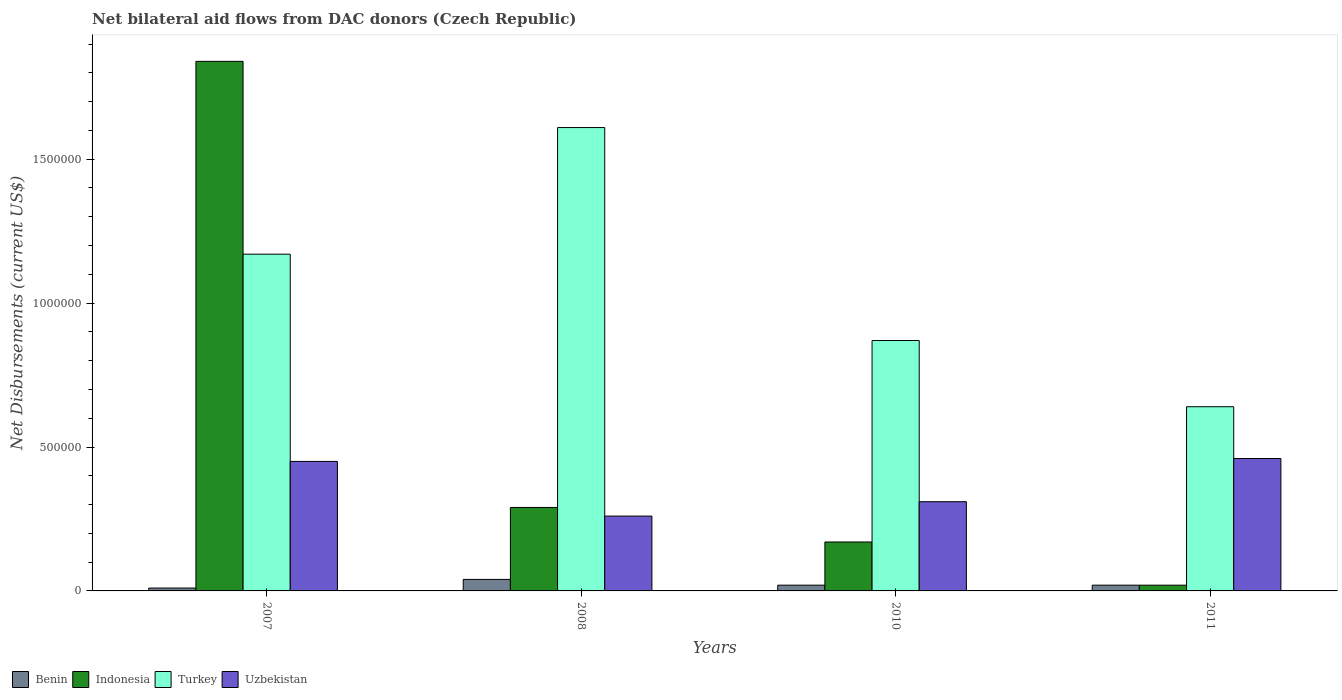How many different coloured bars are there?
Ensure brevity in your answer.  4. How many groups of bars are there?
Give a very brief answer. 4. How many bars are there on the 1st tick from the right?
Your answer should be compact. 4. What is the label of the 4th group of bars from the left?
Your response must be concise. 2011. In how many cases, is the number of bars for a given year not equal to the number of legend labels?
Keep it short and to the point. 0. What is the net bilateral aid flows in Turkey in 2008?
Your answer should be very brief. 1.61e+06. Across all years, what is the minimum net bilateral aid flows in Turkey?
Keep it short and to the point. 6.40e+05. In which year was the net bilateral aid flows in Uzbekistan minimum?
Your answer should be very brief. 2008. What is the total net bilateral aid flows in Indonesia in the graph?
Give a very brief answer. 2.32e+06. What is the difference between the net bilateral aid flows in Turkey in 2008 and that in 2011?
Ensure brevity in your answer.  9.70e+05. What is the difference between the net bilateral aid flows in Turkey in 2007 and the net bilateral aid flows in Benin in 2008?
Your answer should be very brief. 1.13e+06. What is the average net bilateral aid flows in Indonesia per year?
Offer a terse response. 5.80e+05. In the year 2011, what is the difference between the net bilateral aid flows in Benin and net bilateral aid flows in Uzbekistan?
Give a very brief answer. -4.40e+05. In how many years, is the net bilateral aid flows in Uzbekistan greater than 800000 US$?
Provide a short and direct response. 0. What is the difference between the highest and the lowest net bilateral aid flows in Turkey?
Offer a very short reply. 9.70e+05. What does the 4th bar from the left in 2008 represents?
Keep it short and to the point. Uzbekistan. What does the 1st bar from the right in 2008 represents?
Provide a succinct answer. Uzbekistan. Is it the case that in every year, the sum of the net bilateral aid flows in Turkey and net bilateral aid flows in Indonesia is greater than the net bilateral aid flows in Uzbekistan?
Give a very brief answer. Yes. Are the values on the major ticks of Y-axis written in scientific E-notation?
Offer a terse response. No. Does the graph contain any zero values?
Your answer should be very brief. No. Where does the legend appear in the graph?
Provide a short and direct response. Bottom left. How many legend labels are there?
Make the answer very short. 4. What is the title of the graph?
Keep it short and to the point. Net bilateral aid flows from DAC donors (Czech Republic). What is the label or title of the Y-axis?
Make the answer very short. Net Disbursements (current US$). What is the Net Disbursements (current US$) of Indonesia in 2007?
Ensure brevity in your answer.  1.84e+06. What is the Net Disbursements (current US$) of Turkey in 2007?
Keep it short and to the point. 1.17e+06. What is the Net Disbursements (current US$) of Indonesia in 2008?
Your response must be concise. 2.90e+05. What is the Net Disbursements (current US$) in Turkey in 2008?
Your response must be concise. 1.61e+06. What is the Net Disbursements (current US$) of Uzbekistan in 2008?
Make the answer very short. 2.60e+05. What is the Net Disbursements (current US$) in Indonesia in 2010?
Provide a short and direct response. 1.70e+05. What is the Net Disbursements (current US$) of Turkey in 2010?
Offer a very short reply. 8.70e+05. What is the Net Disbursements (current US$) of Uzbekistan in 2010?
Your answer should be very brief. 3.10e+05. What is the Net Disbursements (current US$) of Turkey in 2011?
Your answer should be very brief. 6.40e+05. Across all years, what is the maximum Net Disbursements (current US$) of Indonesia?
Your answer should be very brief. 1.84e+06. Across all years, what is the maximum Net Disbursements (current US$) in Turkey?
Keep it short and to the point. 1.61e+06. Across all years, what is the maximum Net Disbursements (current US$) of Uzbekistan?
Offer a terse response. 4.60e+05. Across all years, what is the minimum Net Disbursements (current US$) in Benin?
Your response must be concise. 10000. Across all years, what is the minimum Net Disbursements (current US$) of Indonesia?
Offer a terse response. 2.00e+04. Across all years, what is the minimum Net Disbursements (current US$) of Turkey?
Your answer should be compact. 6.40e+05. Across all years, what is the minimum Net Disbursements (current US$) of Uzbekistan?
Your response must be concise. 2.60e+05. What is the total Net Disbursements (current US$) in Indonesia in the graph?
Give a very brief answer. 2.32e+06. What is the total Net Disbursements (current US$) of Turkey in the graph?
Make the answer very short. 4.29e+06. What is the total Net Disbursements (current US$) in Uzbekistan in the graph?
Provide a succinct answer. 1.48e+06. What is the difference between the Net Disbursements (current US$) of Benin in 2007 and that in 2008?
Your answer should be very brief. -3.00e+04. What is the difference between the Net Disbursements (current US$) of Indonesia in 2007 and that in 2008?
Provide a short and direct response. 1.55e+06. What is the difference between the Net Disbursements (current US$) of Turkey in 2007 and that in 2008?
Offer a very short reply. -4.40e+05. What is the difference between the Net Disbursements (current US$) of Uzbekistan in 2007 and that in 2008?
Offer a terse response. 1.90e+05. What is the difference between the Net Disbursements (current US$) in Benin in 2007 and that in 2010?
Give a very brief answer. -10000. What is the difference between the Net Disbursements (current US$) in Indonesia in 2007 and that in 2010?
Give a very brief answer. 1.67e+06. What is the difference between the Net Disbursements (current US$) in Benin in 2007 and that in 2011?
Your response must be concise. -10000. What is the difference between the Net Disbursements (current US$) of Indonesia in 2007 and that in 2011?
Provide a succinct answer. 1.82e+06. What is the difference between the Net Disbursements (current US$) in Turkey in 2007 and that in 2011?
Provide a short and direct response. 5.30e+05. What is the difference between the Net Disbursements (current US$) in Turkey in 2008 and that in 2010?
Your answer should be very brief. 7.40e+05. What is the difference between the Net Disbursements (current US$) of Benin in 2008 and that in 2011?
Offer a terse response. 2.00e+04. What is the difference between the Net Disbursements (current US$) of Turkey in 2008 and that in 2011?
Ensure brevity in your answer.  9.70e+05. What is the difference between the Net Disbursements (current US$) in Benin in 2010 and that in 2011?
Make the answer very short. 0. What is the difference between the Net Disbursements (current US$) of Indonesia in 2010 and that in 2011?
Offer a terse response. 1.50e+05. What is the difference between the Net Disbursements (current US$) of Turkey in 2010 and that in 2011?
Provide a short and direct response. 2.30e+05. What is the difference between the Net Disbursements (current US$) in Benin in 2007 and the Net Disbursements (current US$) in Indonesia in 2008?
Offer a terse response. -2.80e+05. What is the difference between the Net Disbursements (current US$) in Benin in 2007 and the Net Disbursements (current US$) in Turkey in 2008?
Your answer should be compact. -1.60e+06. What is the difference between the Net Disbursements (current US$) of Benin in 2007 and the Net Disbursements (current US$) of Uzbekistan in 2008?
Make the answer very short. -2.50e+05. What is the difference between the Net Disbursements (current US$) of Indonesia in 2007 and the Net Disbursements (current US$) of Turkey in 2008?
Your answer should be very brief. 2.30e+05. What is the difference between the Net Disbursements (current US$) of Indonesia in 2007 and the Net Disbursements (current US$) of Uzbekistan in 2008?
Keep it short and to the point. 1.58e+06. What is the difference between the Net Disbursements (current US$) of Turkey in 2007 and the Net Disbursements (current US$) of Uzbekistan in 2008?
Your answer should be very brief. 9.10e+05. What is the difference between the Net Disbursements (current US$) in Benin in 2007 and the Net Disbursements (current US$) in Indonesia in 2010?
Ensure brevity in your answer.  -1.60e+05. What is the difference between the Net Disbursements (current US$) in Benin in 2007 and the Net Disbursements (current US$) in Turkey in 2010?
Your answer should be compact. -8.60e+05. What is the difference between the Net Disbursements (current US$) of Benin in 2007 and the Net Disbursements (current US$) of Uzbekistan in 2010?
Provide a succinct answer. -3.00e+05. What is the difference between the Net Disbursements (current US$) of Indonesia in 2007 and the Net Disbursements (current US$) of Turkey in 2010?
Offer a very short reply. 9.70e+05. What is the difference between the Net Disbursements (current US$) in Indonesia in 2007 and the Net Disbursements (current US$) in Uzbekistan in 2010?
Your answer should be compact. 1.53e+06. What is the difference between the Net Disbursements (current US$) in Turkey in 2007 and the Net Disbursements (current US$) in Uzbekistan in 2010?
Make the answer very short. 8.60e+05. What is the difference between the Net Disbursements (current US$) in Benin in 2007 and the Net Disbursements (current US$) in Indonesia in 2011?
Your response must be concise. -10000. What is the difference between the Net Disbursements (current US$) of Benin in 2007 and the Net Disbursements (current US$) of Turkey in 2011?
Your response must be concise. -6.30e+05. What is the difference between the Net Disbursements (current US$) of Benin in 2007 and the Net Disbursements (current US$) of Uzbekistan in 2011?
Keep it short and to the point. -4.50e+05. What is the difference between the Net Disbursements (current US$) of Indonesia in 2007 and the Net Disbursements (current US$) of Turkey in 2011?
Make the answer very short. 1.20e+06. What is the difference between the Net Disbursements (current US$) of Indonesia in 2007 and the Net Disbursements (current US$) of Uzbekistan in 2011?
Keep it short and to the point. 1.38e+06. What is the difference between the Net Disbursements (current US$) in Turkey in 2007 and the Net Disbursements (current US$) in Uzbekistan in 2011?
Make the answer very short. 7.10e+05. What is the difference between the Net Disbursements (current US$) of Benin in 2008 and the Net Disbursements (current US$) of Indonesia in 2010?
Offer a terse response. -1.30e+05. What is the difference between the Net Disbursements (current US$) of Benin in 2008 and the Net Disbursements (current US$) of Turkey in 2010?
Keep it short and to the point. -8.30e+05. What is the difference between the Net Disbursements (current US$) of Benin in 2008 and the Net Disbursements (current US$) of Uzbekistan in 2010?
Your answer should be compact. -2.70e+05. What is the difference between the Net Disbursements (current US$) in Indonesia in 2008 and the Net Disbursements (current US$) in Turkey in 2010?
Offer a very short reply. -5.80e+05. What is the difference between the Net Disbursements (current US$) of Turkey in 2008 and the Net Disbursements (current US$) of Uzbekistan in 2010?
Offer a terse response. 1.30e+06. What is the difference between the Net Disbursements (current US$) of Benin in 2008 and the Net Disbursements (current US$) of Indonesia in 2011?
Provide a succinct answer. 2.00e+04. What is the difference between the Net Disbursements (current US$) of Benin in 2008 and the Net Disbursements (current US$) of Turkey in 2011?
Make the answer very short. -6.00e+05. What is the difference between the Net Disbursements (current US$) in Benin in 2008 and the Net Disbursements (current US$) in Uzbekistan in 2011?
Your answer should be compact. -4.20e+05. What is the difference between the Net Disbursements (current US$) in Indonesia in 2008 and the Net Disbursements (current US$) in Turkey in 2011?
Keep it short and to the point. -3.50e+05. What is the difference between the Net Disbursements (current US$) in Turkey in 2008 and the Net Disbursements (current US$) in Uzbekistan in 2011?
Make the answer very short. 1.15e+06. What is the difference between the Net Disbursements (current US$) of Benin in 2010 and the Net Disbursements (current US$) of Turkey in 2011?
Make the answer very short. -6.20e+05. What is the difference between the Net Disbursements (current US$) in Benin in 2010 and the Net Disbursements (current US$) in Uzbekistan in 2011?
Your answer should be very brief. -4.40e+05. What is the difference between the Net Disbursements (current US$) in Indonesia in 2010 and the Net Disbursements (current US$) in Turkey in 2011?
Your answer should be very brief. -4.70e+05. What is the difference between the Net Disbursements (current US$) in Indonesia in 2010 and the Net Disbursements (current US$) in Uzbekistan in 2011?
Offer a very short reply. -2.90e+05. What is the difference between the Net Disbursements (current US$) in Turkey in 2010 and the Net Disbursements (current US$) in Uzbekistan in 2011?
Provide a short and direct response. 4.10e+05. What is the average Net Disbursements (current US$) in Benin per year?
Offer a very short reply. 2.25e+04. What is the average Net Disbursements (current US$) in Indonesia per year?
Ensure brevity in your answer.  5.80e+05. What is the average Net Disbursements (current US$) in Turkey per year?
Offer a terse response. 1.07e+06. In the year 2007, what is the difference between the Net Disbursements (current US$) in Benin and Net Disbursements (current US$) in Indonesia?
Provide a short and direct response. -1.83e+06. In the year 2007, what is the difference between the Net Disbursements (current US$) of Benin and Net Disbursements (current US$) of Turkey?
Your response must be concise. -1.16e+06. In the year 2007, what is the difference between the Net Disbursements (current US$) of Benin and Net Disbursements (current US$) of Uzbekistan?
Provide a succinct answer. -4.40e+05. In the year 2007, what is the difference between the Net Disbursements (current US$) of Indonesia and Net Disbursements (current US$) of Turkey?
Provide a succinct answer. 6.70e+05. In the year 2007, what is the difference between the Net Disbursements (current US$) in Indonesia and Net Disbursements (current US$) in Uzbekistan?
Your answer should be very brief. 1.39e+06. In the year 2007, what is the difference between the Net Disbursements (current US$) of Turkey and Net Disbursements (current US$) of Uzbekistan?
Ensure brevity in your answer.  7.20e+05. In the year 2008, what is the difference between the Net Disbursements (current US$) of Benin and Net Disbursements (current US$) of Indonesia?
Provide a short and direct response. -2.50e+05. In the year 2008, what is the difference between the Net Disbursements (current US$) in Benin and Net Disbursements (current US$) in Turkey?
Provide a succinct answer. -1.57e+06. In the year 2008, what is the difference between the Net Disbursements (current US$) in Benin and Net Disbursements (current US$) in Uzbekistan?
Your answer should be compact. -2.20e+05. In the year 2008, what is the difference between the Net Disbursements (current US$) of Indonesia and Net Disbursements (current US$) of Turkey?
Provide a succinct answer. -1.32e+06. In the year 2008, what is the difference between the Net Disbursements (current US$) of Indonesia and Net Disbursements (current US$) of Uzbekistan?
Ensure brevity in your answer.  3.00e+04. In the year 2008, what is the difference between the Net Disbursements (current US$) of Turkey and Net Disbursements (current US$) of Uzbekistan?
Your answer should be very brief. 1.35e+06. In the year 2010, what is the difference between the Net Disbursements (current US$) of Benin and Net Disbursements (current US$) of Indonesia?
Your answer should be very brief. -1.50e+05. In the year 2010, what is the difference between the Net Disbursements (current US$) in Benin and Net Disbursements (current US$) in Turkey?
Make the answer very short. -8.50e+05. In the year 2010, what is the difference between the Net Disbursements (current US$) of Benin and Net Disbursements (current US$) of Uzbekistan?
Offer a very short reply. -2.90e+05. In the year 2010, what is the difference between the Net Disbursements (current US$) in Indonesia and Net Disbursements (current US$) in Turkey?
Give a very brief answer. -7.00e+05. In the year 2010, what is the difference between the Net Disbursements (current US$) of Indonesia and Net Disbursements (current US$) of Uzbekistan?
Keep it short and to the point. -1.40e+05. In the year 2010, what is the difference between the Net Disbursements (current US$) of Turkey and Net Disbursements (current US$) of Uzbekistan?
Your answer should be very brief. 5.60e+05. In the year 2011, what is the difference between the Net Disbursements (current US$) in Benin and Net Disbursements (current US$) in Turkey?
Give a very brief answer. -6.20e+05. In the year 2011, what is the difference between the Net Disbursements (current US$) in Benin and Net Disbursements (current US$) in Uzbekistan?
Ensure brevity in your answer.  -4.40e+05. In the year 2011, what is the difference between the Net Disbursements (current US$) in Indonesia and Net Disbursements (current US$) in Turkey?
Make the answer very short. -6.20e+05. In the year 2011, what is the difference between the Net Disbursements (current US$) in Indonesia and Net Disbursements (current US$) in Uzbekistan?
Your answer should be very brief. -4.40e+05. In the year 2011, what is the difference between the Net Disbursements (current US$) of Turkey and Net Disbursements (current US$) of Uzbekistan?
Offer a very short reply. 1.80e+05. What is the ratio of the Net Disbursements (current US$) in Indonesia in 2007 to that in 2008?
Your answer should be compact. 6.34. What is the ratio of the Net Disbursements (current US$) in Turkey in 2007 to that in 2008?
Your response must be concise. 0.73. What is the ratio of the Net Disbursements (current US$) of Uzbekistan in 2007 to that in 2008?
Provide a succinct answer. 1.73. What is the ratio of the Net Disbursements (current US$) of Indonesia in 2007 to that in 2010?
Provide a succinct answer. 10.82. What is the ratio of the Net Disbursements (current US$) in Turkey in 2007 to that in 2010?
Offer a terse response. 1.34. What is the ratio of the Net Disbursements (current US$) of Uzbekistan in 2007 to that in 2010?
Keep it short and to the point. 1.45. What is the ratio of the Net Disbursements (current US$) in Indonesia in 2007 to that in 2011?
Provide a succinct answer. 92. What is the ratio of the Net Disbursements (current US$) of Turkey in 2007 to that in 2011?
Offer a very short reply. 1.83. What is the ratio of the Net Disbursements (current US$) in Uzbekistan in 2007 to that in 2011?
Provide a short and direct response. 0.98. What is the ratio of the Net Disbursements (current US$) in Indonesia in 2008 to that in 2010?
Your response must be concise. 1.71. What is the ratio of the Net Disbursements (current US$) of Turkey in 2008 to that in 2010?
Provide a succinct answer. 1.85. What is the ratio of the Net Disbursements (current US$) of Uzbekistan in 2008 to that in 2010?
Your response must be concise. 0.84. What is the ratio of the Net Disbursements (current US$) in Turkey in 2008 to that in 2011?
Your response must be concise. 2.52. What is the ratio of the Net Disbursements (current US$) in Uzbekistan in 2008 to that in 2011?
Offer a terse response. 0.57. What is the ratio of the Net Disbursements (current US$) in Benin in 2010 to that in 2011?
Provide a succinct answer. 1. What is the ratio of the Net Disbursements (current US$) in Turkey in 2010 to that in 2011?
Your answer should be compact. 1.36. What is the ratio of the Net Disbursements (current US$) of Uzbekistan in 2010 to that in 2011?
Your answer should be compact. 0.67. What is the difference between the highest and the second highest Net Disbursements (current US$) in Indonesia?
Give a very brief answer. 1.55e+06. What is the difference between the highest and the second highest Net Disbursements (current US$) in Turkey?
Ensure brevity in your answer.  4.40e+05. What is the difference between the highest and the second highest Net Disbursements (current US$) in Uzbekistan?
Make the answer very short. 10000. What is the difference between the highest and the lowest Net Disbursements (current US$) of Indonesia?
Make the answer very short. 1.82e+06. What is the difference between the highest and the lowest Net Disbursements (current US$) in Turkey?
Ensure brevity in your answer.  9.70e+05. What is the difference between the highest and the lowest Net Disbursements (current US$) in Uzbekistan?
Provide a succinct answer. 2.00e+05. 